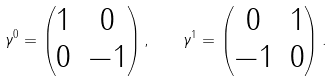Convert formula to latex. <formula><loc_0><loc_0><loc_500><loc_500>\gamma ^ { 0 } = \begin{pmatrix} 1 & 0 \\ 0 & - 1 \end{pmatrix} , \quad \gamma ^ { 1 } = \begin{pmatrix} 0 & 1 \\ - 1 & 0 \end{pmatrix} .</formula> 